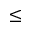Convert formula to latex. <formula><loc_0><loc_0><loc_500><loc_500>\leq</formula> 